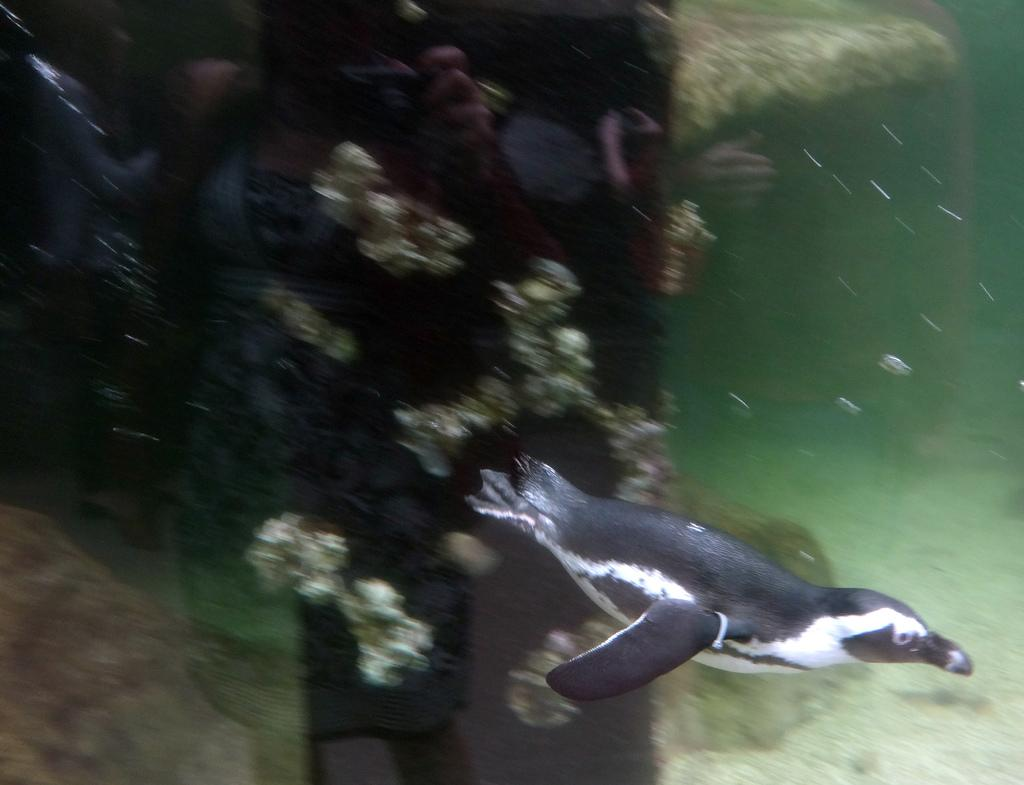What animal can be seen in the water in the image? There is a seal in the water in the image. What type of vegetation is present in the water? There are marine plants in the water. What can be seen at the bottom of the image? There are pebbles at the bottom of the image. How many bikes are visible in the image? There are no bikes present in the image. What is the weight of the sticks in the image? There are no sticks present in the image. 